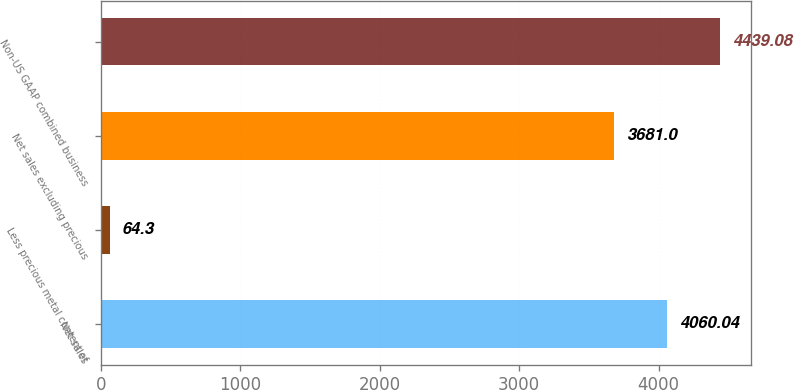<chart> <loc_0><loc_0><loc_500><loc_500><bar_chart><fcel>Net sales<fcel>Less precious metal content of<fcel>Net sales excluding precious<fcel>Non-US GAAP combined business<nl><fcel>4060.04<fcel>64.3<fcel>3681<fcel>4439.08<nl></chart> 